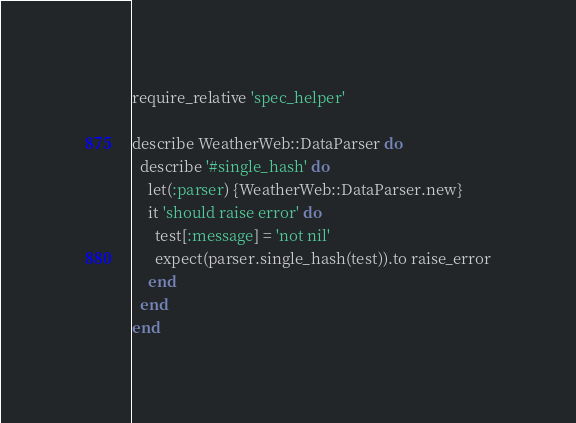<code> <loc_0><loc_0><loc_500><loc_500><_Ruby_>require_relative 'spec_helper'

describe WeatherWeb::DataParser do
  describe '#single_hash' do
    let(:parser) {WeatherWeb::DataParser.new}
    it 'should raise error' do
      test[:message] = 'not nil'
      expect(parser.single_hash(test)).to raise_error
    end
  end
end</code> 